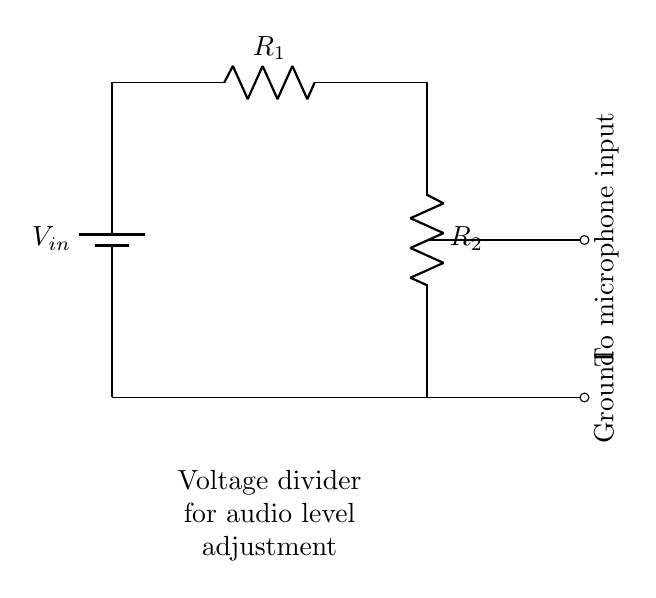What type of circuit is this? The circuit is a voltage divider, which is used to reduce the voltage to a desired level. It consists of two resistors connected in series.
Answer: Voltage divider What are the names of the components used? The components in the circuit are a battery for input voltage and two resistors labeled R1 and R2.
Answer: Battery, R1, R2 What is the purpose of this circuit? The purpose of the circuit is to adjust the audio levels for the microphone input in a film camera.
Answer: Adjust audio levels How many resistors are in the circuit? There are two resistors present in the circuit, R1 and R2.
Answer: Two What happens to the voltage at the output? The voltage at the output is reduced based on the values of R1 and R2, creating a lower voltage suitable for the microphone input.
Answer: Reduced voltage What is connected to the output of the circuit? The output of the circuit is connected to the microphone input for the film camera.
Answer: Microphone input What is the ground connection for? The ground connection serves as a reference point for the circuit and completes the circuit loop for current flow.
Answer: Reference point 